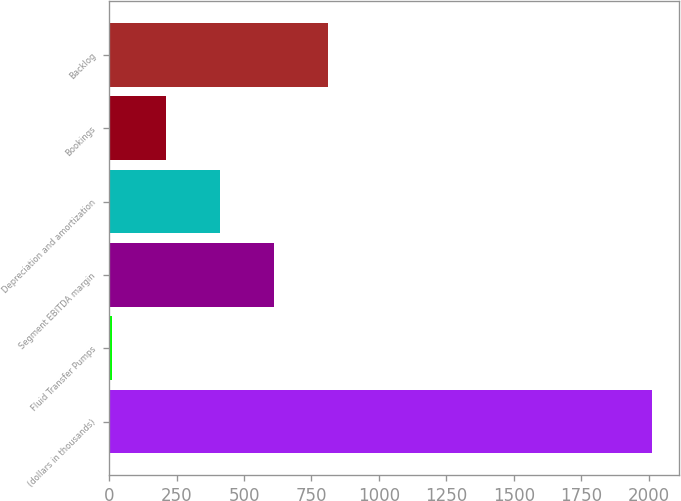<chart> <loc_0><loc_0><loc_500><loc_500><bar_chart><fcel>(dollars in thousands)<fcel>Fluid Transfer Pumps<fcel>Segment EBITDA margin<fcel>Depreciation and amortization<fcel>Bookings<fcel>Backlog<nl><fcel>2012<fcel>11.5<fcel>611.65<fcel>411.6<fcel>211.55<fcel>811.7<nl></chart> 